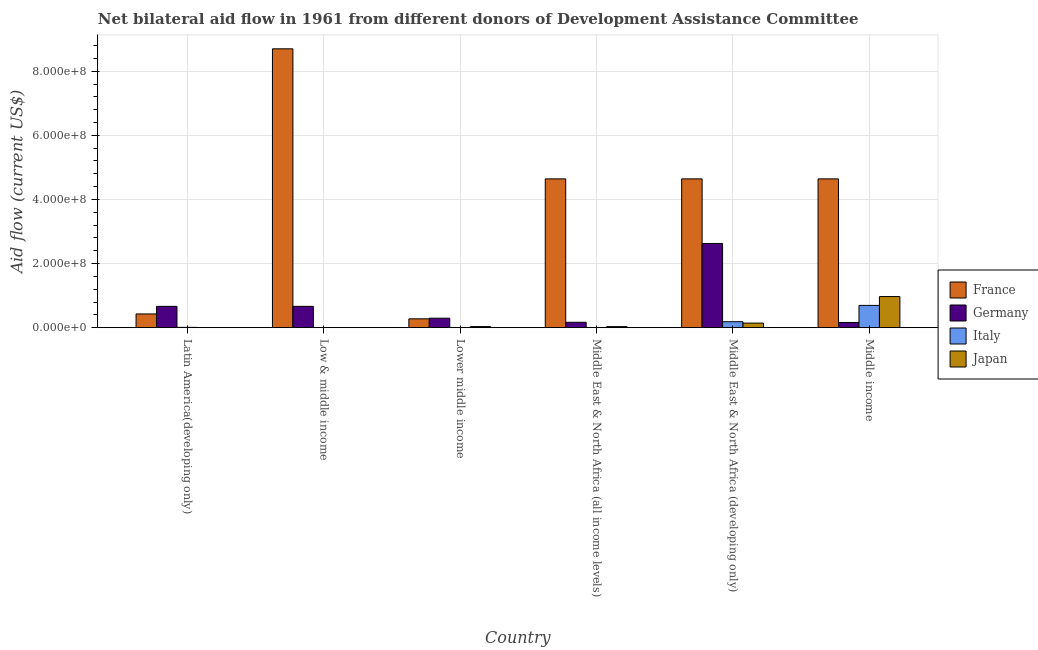How many groups of bars are there?
Your answer should be very brief. 6. Are the number of bars per tick equal to the number of legend labels?
Offer a very short reply. No. Are the number of bars on each tick of the X-axis equal?
Give a very brief answer. No. How many bars are there on the 4th tick from the left?
Keep it short and to the point. 3. What is the label of the 5th group of bars from the left?
Offer a very short reply. Middle East & North Africa (developing only). What is the amount of aid given by france in Low & middle income?
Your response must be concise. 8.70e+08. Across all countries, what is the maximum amount of aid given by italy?
Keep it short and to the point. 6.95e+07. Across all countries, what is the minimum amount of aid given by japan?
Give a very brief answer. 4.00e+04. What is the total amount of aid given by japan in the graph?
Keep it short and to the point. 1.18e+08. What is the difference between the amount of aid given by germany in Lower middle income and that in Middle East & North Africa (all income levels)?
Give a very brief answer. 1.27e+07. What is the difference between the amount of aid given by italy in Lower middle income and the amount of aid given by japan in Low & middle income?
Give a very brief answer. -4.00e+04. What is the average amount of aid given by germany per country?
Your response must be concise. 7.64e+07. What is the difference between the amount of aid given by france and amount of aid given by japan in Middle East & North Africa (all income levels)?
Your answer should be very brief. 4.61e+08. In how many countries, is the amount of aid given by germany greater than 440000000 US$?
Your answer should be compact. 0. What is the ratio of the amount of aid given by japan in Middle East & North Africa (developing only) to that in Middle income?
Ensure brevity in your answer.  0.15. Is the amount of aid given by japan in Latin America(developing only) less than that in Lower middle income?
Your answer should be compact. Yes. Is the difference between the amount of aid given by japan in Latin America(developing only) and Lower middle income greater than the difference between the amount of aid given by germany in Latin America(developing only) and Lower middle income?
Provide a short and direct response. No. What is the difference between the highest and the second highest amount of aid given by italy?
Offer a terse response. 5.10e+07. What is the difference between the highest and the lowest amount of aid given by italy?
Ensure brevity in your answer.  6.95e+07. In how many countries, is the amount of aid given by france greater than the average amount of aid given by france taken over all countries?
Your answer should be compact. 4. Is the sum of the amount of aid given by germany in Latin America(developing only) and Lower middle income greater than the maximum amount of aid given by japan across all countries?
Ensure brevity in your answer.  No. Is it the case that in every country, the sum of the amount of aid given by germany and amount of aid given by japan is greater than the sum of amount of aid given by france and amount of aid given by italy?
Keep it short and to the point. No. Is it the case that in every country, the sum of the amount of aid given by france and amount of aid given by germany is greater than the amount of aid given by italy?
Provide a short and direct response. Yes. How many countries are there in the graph?
Provide a succinct answer. 6. What is the difference between two consecutive major ticks on the Y-axis?
Offer a terse response. 2.00e+08. Are the values on the major ticks of Y-axis written in scientific E-notation?
Your answer should be compact. Yes. How are the legend labels stacked?
Make the answer very short. Vertical. What is the title of the graph?
Make the answer very short. Net bilateral aid flow in 1961 from different donors of Development Assistance Committee. Does "Water" appear as one of the legend labels in the graph?
Your answer should be compact. No. What is the label or title of the X-axis?
Offer a very short reply. Country. What is the label or title of the Y-axis?
Your response must be concise. Aid flow (current US$). What is the Aid flow (current US$) in France in Latin America(developing only)?
Provide a succinct answer. 4.28e+07. What is the Aid flow (current US$) of Germany in Latin America(developing only)?
Make the answer very short. 6.65e+07. What is the Aid flow (current US$) of Italy in Latin America(developing only)?
Make the answer very short. 9.40e+05. What is the Aid flow (current US$) of France in Low & middle income?
Your answer should be compact. 8.70e+08. What is the Aid flow (current US$) of Germany in Low & middle income?
Your response must be concise. 6.65e+07. What is the Aid flow (current US$) in Japan in Low & middle income?
Make the answer very short. 4.00e+04. What is the Aid flow (current US$) of France in Lower middle income?
Provide a succinct answer. 2.76e+07. What is the Aid flow (current US$) of Germany in Lower middle income?
Your answer should be compact. 2.95e+07. What is the Aid flow (current US$) in Italy in Lower middle income?
Provide a succinct answer. 0. What is the Aid flow (current US$) in Japan in Lower middle income?
Your answer should be very brief. 3.34e+06. What is the Aid flow (current US$) in France in Middle East & North Africa (all income levels)?
Keep it short and to the point. 4.64e+08. What is the Aid flow (current US$) in Germany in Middle East & North Africa (all income levels)?
Keep it short and to the point. 1.68e+07. What is the Aid flow (current US$) in Japan in Middle East & North Africa (all income levels)?
Offer a very short reply. 3.33e+06. What is the Aid flow (current US$) in France in Middle East & North Africa (developing only)?
Ensure brevity in your answer.  4.64e+08. What is the Aid flow (current US$) of Germany in Middle East & North Africa (developing only)?
Your answer should be very brief. 2.63e+08. What is the Aid flow (current US$) of Italy in Middle East & North Africa (developing only)?
Your response must be concise. 1.85e+07. What is the Aid flow (current US$) in Japan in Middle East & North Africa (developing only)?
Give a very brief answer. 1.43e+07. What is the Aid flow (current US$) in France in Middle income?
Keep it short and to the point. 4.64e+08. What is the Aid flow (current US$) of Germany in Middle income?
Your answer should be compact. 1.62e+07. What is the Aid flow (current US$) of Italy in Middle income?
Offer a very short reply. 6.95e+07. What is the Aid flow (current US$) of Japan in Middle income?
Make the answer very short. 9.71e+07. Across all countries, what is the maximum Aid flow (current US$) in France?
Provide a short and direct response. 8.70e+08. Across all countries, what is the maximum Aid flow (current US$) of Germany?
Make the answer very short. 2.63e+08. Across all countries, what is the maximum Aid flow (current US$) of Italy?
Make the answer very short. 6.95e+07. Across all countries, what is the maximum Aid flow (current US$) in Japan?
Offer a very short reply. 9.71e+07. Across all countries, what is the minimum Aid flow (current US$) in France?
Your answer should be compact. 2.76e+07. Across all countries, what is the minimum Aid flow (current US$) of Germany?
Give a very brief answer. 1.62e+07. Across all countries, what is the minimum Aid flow (current US$) in Japan?
Your response must be concise. 4.00e+04. What is the total Aid flow (current US$) in France in the graph?
Give a very brief answer. 2.33e+09. What is the total Aid flow (current US$) of Germany in the graph?
Keep it short and to the point. 4.58e+08. What is the total Aid flow (current US$) in Italy in the graph?
Offer a terse response. 8.90e+07. What is the total Aid flow (current US$) of Japan in the graph?
Give a very brief answer. 1.18e+08. What is the difference between the Aid flow (current US$) of France in Latin America(developing only) and that in Low & middle income?
Keep it short and to the point. -8.27e+08. What is the difference between the Aid flow (current US$) in Italy in Latin America(developing only) and that in Low & middle income?
Your response must be concise. 8.50e+05. What is the difference between the Aid flow (current US$) in France in Latin America(developing only) and that in Lower middle income?
Your answer should be compact. 1.52e+07. What is the difference between the Aid flow (current US$) of Germany in Latin America(developing only) and that in Lower middle income?
Your answer should be compact. 3.70e+07. What is the difference between the Aid flow (current US$) of Japan in Latin America(developing only) and that in Lower middle income?
Keep it short and to the point. -3.29e+06. What is the difference between the Aid flow (current US$) of France in Latin America(developing only) and that in Middle East & North Africa (all income levels)?
Offer a terse response. -4.21e+08. What is the difference between the Aid flow (current US$) of Germany in Latin America(developing only) and that in Middle East & North Africa (all income levels)?
Ensure brevity in your answer.  4.97e+07. What is the difference between the Aid flow (current US$) of Japan in Latin America(developing only) and that in Middle East & North Africa (all income levels)?
Provide a short and direct response. -3.28e+06. What is the difference between the Aid flow (current US$) of France in Latin America(developing only) and that in Middle East & North Africa (developing only)?
Your response must be concise. -4.21e+08. What is the difference between the Aid flow (current US$) in Germany in Latin America(developing only) and that in Middle East & North Africa (developing only)?
Offer a very short reply. -1.96e+08. What is the difference between the Aid flow (current US$) in Italy in Latin America(developing only) and that in Middle East & North Africa (developing only)?
Provide a succinct answer. -1.76e+07. What is the difference between the Aid flow (current US$) in Japan in Latin America(developing only) and that in Middle East & North Africa (developing only)?
Give a very brief answer. -1.42e+07. What is the difference between the Aid flow (current US$) in France in Latin America(developing only) and that in Middle income?
Keep it short and to the point. -4.21e+08. What is the difference between the Aid flow (current US$) of Germany in Latin America(developing only) and that in Middle income?
Ensure brevity in your answer.  5.03e+07. What is the difference between the Aid flow (current US$) of Italy in Latin America(developing only) and that in Middle income?
Your answer should be compact. -6.85e+07. What is the difference between the Aid flow (current US$) in Japan in Latin America(developing only) and that in Middle income?
Your answer should be very brief. -9.70e+07. What is the difference between the Aid flow (current US$) in France in Low & middle income and that in Lower middle income?
Offer a terse response. 8.42e+08. What is the difference between the Aid flow (current US$) in Germany in Low & middle income and that in Lower middle income?
Offer a very short reply. 3.70e+07. What is the difference between the Aid flow (current US$) of Japan in Low & middle income and that in Lower middle income?
Provide a short and direct response. -3.30e+06. What is the difference between the Aid flow (current US$) of France in Low & middle income and that in Middle East & North Africa (all income levels)?
Keep it short and to the point. 4.06e+08. What is the difference between the Aid flow (current US$) of Germany in Low & middle income and that in Middle East & North Africa (all income levels)?
Keep it short and to the point. 4.97e+07. What is the difference between the Aid flow (current US$) in Japan in Low & middle income and that in Middle East & North Africa (all income levels)?
Give a very brief answer. -3.29e+06. What is the difference between the Aid flow (current US$) in France in Low & middle income and that in Middle East & North Africa (developing only)?
Ensure brevity in your answer.  4.06e+08. What is the difference between the Aid flow (current US$) of Germany in Low & middle income and that in Middle East & North Africa (developing only)?
Ensure brevity in your answer.  -1.96e+08. What is the difference between the Aid flow (current US$) of Italy in Low & middle income and that in Middle East & North Africa (developing only)?
Give a very brief answer. -1.84e+07. What is the difference between the Aid flow (current US$) in Japan in Low & middle income and that in Middle East & North Africa (developing only)?
Offer a very short reply. -1.42e+07. What is the difference between the Aid flow (current US$) of France in Low & middle income and that in Middle income?
Provide a short and direct response. 4.06e+08. What is the difference between the Aid flow (current US$) in Germany in Low & middle income and that in Middle income?
Your answer should be very brief. 5.03e+07. What is the difference between the Aid flow (current US$) of Italy in Low & middle income and that in Middle income?
Offer a terse response. -6.94e+07. What is the difference between the Aid flow (current US$) of Japan in Low & middle income and that in Middle income?
Your answer should be compact. -9.70e+07. What is the difference between the Aid flow (current US$) of France in Lower middle income and that in Middle East & North Africa (all income levels)?
Offer a very short reply. -4.37e+08. What is the difference between the Aid flow (current US$) of Germany in Lower middle income and that in Middle East & North Africa (all income levels)?
Provide a succinct answer. 1.27e+07. What is the difference between the Aid flow (current US$) in France in Lower middle income and that in Middle East & North Africa (developing only)?
Your answer should be very brief. -4.37e+08. What is the difference between the Aid flow (current US$) in Germany in Lower middle income and that in Middle East & North Africa (developing only)?
Your answer should be compact. -2.33e+08. What is the difference between the Aid flow (current US$) of Japan in Lower middle income and that in Middle East & North Africa (developing only)?
Provide a succinct answer. -1.09e+07. What is the difference between the Aid flow (current US$) of France in Lower middle income and that in Middle income?
Provide a succinct answer. -4.37e+08. What is the difference between the Aid flow (current US$) of Germany in Lower middle income and that in Middle income?
Offer a very short reply. 1.33e+07. What is the difference between the Aid flow (current US$) in Japan in Lower middle income and that in Middle income?
Your response must be concise. -9.37e+07. What is the difference between the Aid flow (current US$) of France in Middle East & North Africa (all income levels) and that in Middle East & North Africa (developing only)?
Keep it short and to the point. 0. What is the difference between the Aid flow (current US$) of Germany in Middle East & North Africa (all income levels) and that in Middle East & North Africa (developing only)?
Provide a succinct answer. -2.46e+08. What is the difference between the Aid flow (current US$) in Japan in Middle East & North Africa (all income levels) and that in Middle East & North Africa (developing only)?
Your answer should be compact. -1.10e+07. What is the difference between the Aid flow (current US$) of Germany in Middle East & North Africa (all income levels) and that in Middle income?
Ensure brevity in your answer.  6.10e+05. What is the difference between the Aid flow (current US$) in Japan in Middle East & North Africa (all income levels) and that in Middle income?
Your answer should be very brief. -9.37e+07. What is the difference between the Aid flow (current US$) in France in Middle East & North Africa (developing only) and that in Middle income?
Offer a very short reply. 0. What is the difference between the Aid flow (current US$) in Germany in Middle East & North Africa (developing only) and that in Middle income?
Your answer should be compact. 2.46e+08. What is the difference between the Aid flow (current US$) of Italy in Middle East & North Africa (developing only) and that in Middle income?
Offer a terse response. -5.10e+07. What is the difference between the Aid flow (current US$) of Japan in Middle East & North Africa (developing only) and that in Middle income?
Provide a short and direct response. -8.28e+07. What is the difference between the Aid flow (current US$) in France in Latin America(developing only) and the Aid flow (current US$) in Germany in Low & middle income?
Provide a short and direct response. -2.37e+07. What is the difference between the Aid flow (current US$) of France in Latin America(developing only) and the Aid flow (current US$) of Italy in Low & middle income?
Your answer should be very brief. 4.27e+07. What is the difference between the Aid flow (current US$) of France in Latin America(developing only) and the Aid flow (current US$) of Japan in Low & middle income?
Keep it short and to the point. 4.28e+07. What is the difference between the Aid flow (current US$) of Germany in Latin America(developing only) and the Aid flow (current US$) of Italy in Low & middle income?
Give a very brief answer. 6.64e+07. What is the difference between the Aid flow (current US$) in Germany in Latin America(developing only) and the Aid flow (current US$) in Japan in Low & middle income?
Ensure brevity in your answer.  6.65e+07. What is the difference between the Aid flow (current US$) of France in Latin America(developing only) and the Aid flow (current US$) of Germany in Lower middle income?
Your answer should be compact. 1.33e+07. What is the difference between the Aid flow (current US$) in France in Latin America(developing only) and the Aid flow (current US$) in Japan in Lower middle income?
Provide a short and direct response. 3.95e+07. What is the difference between the Aid flow (current US$) in Germany in Latin America(developing only) and the Aid flow (current US$) in Japan in Lower middle income?
Your answer should be very brief. 6.32e+07. What is the difference between the Aid flow (current US$) of Italy in Latin America(developing only) and the Aid flow (current US$) of Japan in Lower middle income?
Make the answer very short. -2.40e+06. What is the difference between the Aid flow (current US$) in France in Latin America(developing only) and the Aid flow (current US$) in Germany in Middle East & North Africa (all income levels)?
Ensure brevity in your answer.  2.60e+07. What is the difference between the Aid flow (current US$) of France in Latin America(developing only) and the Aid flow (current US$) of Japan in Middle East & North Africa (all income levels)?
Your answer should be very brief. 3.95e+07. What is the difference between the Aid flow (current US$) in Germany in Latin America(developing only) and the Aid flow (current US$) in Japan in Middle East & North Africa (all income levels)?
Ensure brevity in your answer.  6.32e+07. What is the difference between the Aid flow (current US$) in Italy in Latin America(developing only) and the Aid flow (current US$) in Japan in Middle East & North Africa (all income levels)?
Provide a succinct answer. -2.39e+06. What is the difference between the Aid flow (current US$) in France in Latin America(developing only) and the Aid flow (current US$) in Germany in Middle East & North Africa (developing only)?
Provide a succinct answer. -2.20e+08. What is the difference between the Aid flow (current US$) in France in Latin America(developing only) and the Aid flow (current US$) in Italy in Middle East & North Africa (developing only)?
Your answer should be compact. 2.43e+07. What is the difference between the Aid flow (current US$) in France in Latin America(developing only) and the Aid flow (current US$) in Japan in Middle East & North Africa (developing only)?
Your response must be concise. 2.85e+07. What is the difference between the Aid flow (current US$) in Germany in Latin America(developing only) and the Aid flow (current US$) in Italy in Middle East & North Africa (developing only)?
Keep it short and to the point. 4.80e+07. What is the difference between the Aid flow (current US$) of Germany in Latin America(developing only) and the Aid flow (current US$) of Japan in Middle East & North Africa (developing only)?
Offer a terse response. 5.22e+07. What is the difference between the Aid flow (current US$) in Italy in Latin America(developing only) and the Aid flow (current US$) in Japan in Middle East & North Africa (developing only)?
Your answer should be very brief. -1.33e+07. What is the difference between the Aid flow (current US$) of France in Latin America(developing only) and the Aid flow (current US$) of Germany in Middle income?
Make the answer very short. 2.66e+07. What is the difference between the Aid flow (current US$) of France in Latin America(developing only) and the Aid flow (current US$) of Italy in Middle income?
Your answer should be very brief. -2.67e+07. What is the difference between the Aid flow (current US$) in France in Latin America(developing only) and the Aid flow (current US$) in Japan in Middle income?
Give a very brief answer. -5.43e+07. What is the difference between the Aid flow (current US$) in Germany in Latin America(developing only) and the Aid flow (current US$) in Italy in Middle income?
Make the answer very short. -2.97e+06. What is the difference between the Aid flow (current US$) in Germany in Latin America(developing only) and the Aid flow (current US$) in Japan in Middle income?
Make the answer very short. -3.06e+07. What is the difference between the Aid flow (current US$) in Italy in Latin America(developing only) and the Aid flow (current US$) in Japan in Middle income?
Ensure brevity in your answer.  -9.61e+07. What is the difference between the Aid flow (current US$) of France in Low & middle income and the Aid flow (current US$) of Germany in Lower middle income?
Provide a succinct answer. 8.40e+08. What is the difference between the Aid flow (current US$) in France in Low & middle income and the Aid flow (current US$) in Japan in Lower middle income?
Offer a very short reply. 8.67e+08. What is the difference between the Aid flow (current US$) in Germany in Low & middle income and the Aid flow (current US$) in Japan in Lower middle income?
Your response must be concise. 6.32e+07. What is the difference between the Aid flow (current US$) in Italy in Low & middle income and the Aid flow (current US$) in Japan in Lower middle income?
Make the answer very short. -3.25e+06. What is the difference between the Aid flow (current US$) of France in Low & middle income and the Aid flow (current US$) of Germany in Middle East & North Africa (all income levels)?
Give a very brief answer. 8.53e+08. What is the difference between the Aid flow (current US$) of France in Low & middle income and the Aid flow (current US$) of Japan in Middle East & North Africa (all income levels)?
Your response must be concise. 8.67e+08. What is the difference between the Aid flow (current US$) in Germany in Low & middle income and the Aid flow (current US$) in Japan in Middle East & North Africa (all income levels)?
Your answer should be very brief. 6.32e+07. What is the difference between the Aid flow (current US$) in Italy in Low & middle income and the Aid flow (current US$) in Japan in Middle East & North Africa (all income levels)?
Ensure brevity in your answer.  -3.24e+06. What is the difference between the Aid flow (current US$) of France in Low & middle income and the Aid flow (current US$) of Germany in Middle East & North Africa (developing only)?
Give a very brief answer. 6.07e+08. What is the difference between the Aid flow (current US$) of France in Low & middle income and the Aid flow (current US$) of Italy in Middle East & North Africa (developing only)?
Offer a very short reply. 8.51e+08. What is the difference between the Aid flow (current US$) of France in Low & middle income and the Aid flow (current US$) of Japan in Middle East & North Africa (developing only)?
Keep it short and to the point. 8.56e+08. What is the difference between the Aid flow (current US$) of Germany in Low & middle income and the Aid flow (current US$) of Italy in Middle East & North Africa (developing only)?
Keep it short and to the point. 4.80e+07. What is the difference between the Aid flow (current US$) in Germany in Low & middle income and the Aid flow (current US$) in Japan in Middle East & North Africa (developing only)?
Give a very brief answer. 5.22e+07. What is the difference between the Aid flow (current US$) in Italy in Low & middle income and the Aid flow (current US$) in Japan in Middle East & North Africa (developing only)?
Your answer should be very brief. -1.42e+07. What is the difference between the Aid flow (current US$) in France in Low & middle income and the Aid flow (current US$) in Germany in Middle income?
Ensure brevity in your answer.  8.54e+08. What is the difference between the Aid flow (current US$) of France in Low & middle income and the Aid flow (current US$) of Italy in Middle income?
Make the answer very short. 8.01e+08. What is the difference between the Aid flow (current US$) in France in Low & middle income and the Aid flow (current US$) in Japan in Middle income?
Make the answer very short. 7.73e+08. What is the difference between the Aid flow (current US$) of Germany in Low & middle income and the Aid flow (current US$) of Italy in Middle income?
Provide a succinct answer. -2.97e+06. What is the difference between the Aid flow (current US$) of Germany in Low & middle income and the Aid flow (current US$) of Japan in Middle income?
Provide a succinct answer. -3.06e+07. What is the difference between the Aid flow (current US$) in Italy in Low & middle income and the Aid flow (current US$) in Japan in Middle income?
Make the answer very short. -9.70e+07. What is the difference between the Aid flow (current US$) of France in Lower middle income and the Aid flow (current US$) of Germany in Middle East & North Africa (all income levels)?
Offer a terse response. 1.08e+07. What is the difference between the Aid flow (current US$) of France in Lower middle income and the Aid flow (current US$) of Japan in Middle East & North Africa (all income levels)?
Make the answer very short. 2.43e+07. What is the difference between the Aid flow (current US$) in Germany in Lower middle income and the Aid flow (current US$) in Japan in Middle East & North Africa (all income levels)?
Provide a succinct answer. 2.62e+07. What is the difference between the Aid flow (current US$) in France in Lower middle income and the Aid flow (current US$) in Germany in Middle East & North Africa (developing only)?
Make the answer very short. -2.35e+08. What is the difference between the Aid flow (current US$) of France in Lower middle income and the Aid flow (current US$) of Italy in Middle East & North Africa (developing only)?
Provide a succinct answer. 9.08e+06. What is the difference between the Aid flow (current US$) in France in Lower middle income and the Aid flow (current US$) in Japan in Middle East & North Africa (developing only)?
Give a very brief answer. 1.33e+07. What is the difference between the Aid flow (current US$) in Germany in Lower middle income and the Aid flow (current US$) in Italy in Middle East & North Africa (developing only)?
Offer a terse response. 1.10e+07. What is the difference between the Aid flow (current US$) of Germany in Lower middle income and the Aid flow (current US$) of Japan in Middle East & North Africa (developing only)?
Give a very brief answer. 1.52e+07. What is the difference between the Aid flow (current US$) of France in Lower middle income and the Aid flow (current US$) of Germany in Middle income?
Provide a short and direct response. 1.14e+07. What is the difference between the Aid flow (current US$) in France in Lower middle income and the Aid flow (current US$) in Italy in Middle income?
Offer a very short reply. -4.19e+07. What is the difference between the Aid flow (current US$) in France in Lower middle income and the Aid flow (current US$) in Japan in Middle income?
Offer a very short reply. -6.95e+07. What is the difference between the Aid flow (current US$) in Germany in Lower middle income and the Aid flow (current US$) in Italy in Middle income?
Your response must be concise. -4.00e+07. What is the difference between the Aid flow (current US$) of Germany in Lower middle income and the Aid flow (current US$) of Japan in Middle income?
Your answer should be very brief. -6.75e+07. What is the difference between the Aid flow (current US$) in France in Middle East & North Africa (all income levels) and the Aid flow (current US$) in Germany in Middle East & North Africa (developing only)?
Keep it short and to the point. 2.02e+08. What is the difference between the Aid flow (current US$) of France in Middle East & North Africa (all income levels) and the Aid flow (current US$) of Italy in Middle East & North Africa (developing only)?
Make the answer very short. 4.46e+08. What is the difference between the Aid flow (current US$) of France in Middle East & North Africa (all income levels) and the Aid flow (current US$) of Japan in Middle East & North Africa (developing only)?
Your answer should be very brief. 4.50e+08. What is the difference between the Aid flow (current US$) of Germany in Middle East & North Africa (all income levels) and the Aid flow (current US$) of Italy in Middle East & North Africa (developing only)?
Make the answer very short. -1.71e+06. What is the difference between the Aid flow (current US$) of Germany in Middle East & North Africa (all income levels) and the Aid flow (current US$) of Japan in Middle East & North Africa (developing only)?
Offer a terse response. 2.53e+06. What is the difference between the Aid flow (current US$) of France in Middle East & North Africa (all income levels) and the Aid flow (current US$) of Germany in Middle income?
Your response must be concise. 4.48e+08. What is the difference between the Aid flow (current US$) of France in Middle East & North Africa (all income levels) and the Aid flow (current US$) of Italy in Middle income?
Your answer should be compact. 3.95e+08. What is the difference between the Aid flow (current US$) of France in Middle East & North Africa (all income levels) and the Aid flow (current US$) of Japan in Middle income?
Give a very brief answer. 3.67e+08. What is the difference between the Aid flow (current US$) in Germany in Middle East & North Africa (all income levels) and the Aid flow (current US$) in Italy in Middle income?
Offer a very short reply. -5.27e+07. What is the difference between the Aid flow (current US$) of Germany in Middle East & North Africa (all income levels) and the Aid flow (current US$) of Japan in Middle income?
Give a very brief answer. -8.02e+07. What is the difference between the Aid flow (current US$) of France in Middle East & North Africa (developing only) and the Aid flow (current US$) of Germany in Middle income?
Keep it short and to the point. 4.48e+08. What is the difference between the Aid flow (current US$) of France in Middle East & North Africa (developing only) and the Aid flow (current US$) of Italy in Middle income?
Make the answer very short. 3.95e+08. What is the difference between the Aid flow (current US$) of France in Middle East & North Africa (developing only) and the Aid flow (current US$) of Japan in Middle income?
Offer a very short reply. 3.67e+08. What is the difference between the Aid flow (current US$) of Germany in Middle East & North Africa (developing only) and the Aid flow (current US$) of Italy in Middle income?
Make the answer very short. 1.93e+08. What is the difference between the Aid flow (current US$) in Germany in Middle East & North Africa (developing only) and the Aid flow (current US$) in Japan in Middle income?
Your answer should be compact. 1.66e+08. What is the difference between the Aid flow (current US$) of Italy in Middle East & North Africa (developing only) and the Aid flow (current US$) of Japan in Middle income?
Give a very brief answer. -7.85e+07. What is the average Aid flow (current US$) in France per country?
Your answer should be compact. 3.89e+08. What is the average Aid flow (current US$) of Germany per country?
Provide a succinct answer. 7.64e+07. What is the average Aid flow (current US$) of Italy per country?
Your answer should be compact. 1.48e+07. What is the average Aid flow (current US$) of Japan per country?
Your answer should be very brief. 1.97e+07. What is the difference between the Aid flow (current US$) in France and Aid flow (current US$) in Germany in Latin America(developing only)?
Your response must be concise. -2.37e+07. What is the difference between the Aid flow (current US$) of France and Aid flow (current US$) of Italy in Latin America(developing only)?
Provide a succinct answer. 4.19e+07. What is the difference between the Aid flow (current US$) in France and Aid flow (current US$) in Japan in Latin America(developing only)?
Keep it short and to the point. 4.28e+07. What is the difference between the Aid flow (current US$) of Germany and Aid flow (current US$) of Italy in Latin America(developing only)?
Give a very brief answer. 6.56e+07. What is the difference between the Aid flow (current US$) of Germany and Aid flow (current US$) of Japan in Latin America(developing only)?
Provide a succinct answer. 6.65e+07. What is the difference between the Aid flow (current US$) in Italy and Aid flow (current US$) in Japan in Latin America(developing only)?
Your answer should be compact. 8.90e+05. What is the difference between the Aid flow (current US$) in France and Aid flow (current US$) in Germany in Low & middle income?
Your answer should be very brief. 8.03e+08. What is the difference between the Aid flow (current US$) in France and Aid flow (current US$) in Italy in Low & middle income?
Offer a very short reply. 8.70e+08. What is the difference between the Aid flow (current US$) of France and Aid flow (current US$) of Japan in Low & middle income?
Provide a short and direct response. 8.70e+08. What is the difference between the Aid flow (current US$) of Germany and Aid flow (current US$) of Italy in Low & middle income?
Your response must be concise. 6.64e+07. What is the difference between the Aid flow (current US$) of Germany and Aid flow (current US$) of Japan in Low & middle income?
Ensure brevity in your answer.  6.65e+07. What is the difference between the Aid flow (current US$) in France and Aid flow (current US$) in Germany in Lower middle income?
Make the answer very short. -1.92e+06. What is the difference between the Aid flow (current US$) in France and Aid flow (current US$) in Japan in Lower middle income?
Your answer should be compact. 2.43e+07. What is the difference between the Aid flow (current US$) of Germany and Aid flow (current US$) of Japan in Lower middle income?
Offer a very short reply. 2.62e+07. What is the difference between the Aid flow (current US$) in France and Aid flow (current US$) in Germany in Middle East & North Africa (all income levels)?
Ensure brevity in your answer.  4.47e+08. What is the difference between the Aid flow (current US$) in France and Aid flow (current US$) in Japan in Middle East & North Africa (all income levels)?
Keep it short and to the point. 4.61e+08. What is the difference between the Aid flow (current US$) of Germany and Aid flow (current US$) of Japan in Middle East & North Africa (all income levels)?
Give a very brief answer. 1.35e+07. What is the difference between the Aid flow (current US$) in France and Aid flow (current US$) in Germany in Middle East & North Africa (developing only)?
Your answer should be compact. 2.02e+08. What is the difference between the Aid flow (current US$) in France and Aid flow (current US$) in Italy in Middle East & North Africa (developing only)?
Your answer should be very brief. 4.46e+08. What is the difference between the Aid flow (current US$) of France and Aid flow (current US$) of Japan in Middle East & North Africa (developing only)?
Your answer should be compact. 4.50e+08. What is the difference between the Aid flow (current US$) in Germany and Aid flow (current US$) in Italy in Middle East & North Africa (developing only)?
Ensure brevity in your answer.  2.44e+08. What is the difference between the Aid flow (current US$) in Germany and Aid flow (current US$) in Japan in Middle East & North Africa (developing only)?
Your response must be concise. 2.48e+08. What is the difference between the Aid flow (current US$) of Italy and Aid flow (current US$) of Japan in Middle East & North Africa (developing only)?
Provide a succinct answer. 4.24e+06. What is the difference between the Aid flow (current US$) in France and Aid flow (current US$) in Germany in Middle income?
Provide a short and direct response. 4.48e+08. What is the difference between the Aid flow (current US$) in France and Aid flow (current US$) in Italy in Middle income?
Provide a succinct answer. 3.95e+08. What is the difference between the Aid flow (current US$) in France and Aid flow (current US$) in Japan in Middle income?
Your answer should be very brief. 3.67e+08. What is the difference between the Aid flow (current US$) in Germany and Aid flow (current US$) in Italy in Middle income?
Your response must be concise. -5.33e+07. What is the difference between the Aid flow (current US$) of Germany and Aid flow (current US$) of Japan in Middle income?
Make the answer very short. -8.09e+07. What is the difference between the Aid flow (current US$) of Italy and Aid flow (current US$) of Japan in Middle income?
Provide a short and direct response. -2.76e+07. What is the ratio of the Aid flow (current US$) of France in Latin America(developing only) to that in Low & middle income?
Ensure brevity in your answer.  0.05. What is the ratio of the Aid flow (current US$) of Germany in Latin America(developing only) to that in Low & middle income?
Ensure brevity in your answer.  1. What is the ratio of the Aid flow (current US$) of Italy in Latin America(developing only) to that in Low & middle income?
Give a very brief answer. 10.44. What is the ratio of the Aid flow (current US$) in France in Latin America(developing only) to that in Lower middle income?
Your answer should be compact. 1.55. What is the ratio of the Aid flow (current US$) in Germany in Latin America(developing only) to that in Lower middle income?
Ensure brevity in your answer.  2.25. What is the ratio of the Aid flow (current US$) of Japan in Latin America(developing only) to that in Lower middle income?
Provide a short and direct response. 0.01. What is the ratio of the Aid flow (current US$) in France in Latin America(developing only) to that in Middle East & North Africa (all income levels)?
Your response must be concise. 0.09. What is the ratio of the Aid flow (current US$) of Germany in Latin America(developing only) to that in Middle East & North Africa (all income levels)?
Your answer should be compact. 3.96. What is the ratio of the Aid flow (current US$) in Japan in Latin America(developing only) to that in Middle East & North Africa (all income levels)?
Make the answer very short. 0.01. What is the ratio of the Aid flow (current US$) in France in Latin America(developing only) to that in Middle East & North Africa (developing only)?
Your response must be concise. 0.09. What is the ratio of the Aid flow (current US$) of Germany in Latin America(developing only) to that in Middle East & North Africa (developing only)?
Offer a very short reply. 0.25. What is the ratio of the Aid flow (current US$) of Italy in Latin America(developing only) to that in Middle East & North Africa (developing only)?
Keep it short and to the point. 0.05. What is the ratio of the Aid flow (current US$) in Japan in Latin America(developing only) to that in Middle East & North Africa (developing only)?
Your answer should be very brief. 0. What is the ratio of the Aid flow (current US$) of France in Latin America(developing only) to that in Middle income?
Give a very brief answer. 0.09. What is the ratio of the Aid flow (current US$) of Germany in Latin America(developing only) to that in Middle income?
Keep it short and to the point. 4.11. What is the ratio of the Aid flow (current US$) in Italy in Latin America(developing only) to that in Middle income?
Offer a terse response. 0.01. What is the ratio of the Aid flow (current US$) in France in Low & middle income to that in Lower middle income?
Provide a succinct answer. 31.52. What is the ratio of the Aid flow (current US$) of Germany in Low & middle income to that in Lower middle income?
Give a very brief answer. 2.25. What is the ratio of the Aid flow (current US$) of Japan in Low & middle income to that in Lower middle income?
Keep it short and to the point. 0.01. What is the ratio of the Aid flow (current US$) in France in Low & middle income to that in Middle East & North Africa (all income levels)?
Make the answer very short. 1.87. What is the ratio of the Aid flow (current US$) of Germany in Low & middle income to that in Middle East & North Africa (all income levels)?
Your answer should be compact. 3.96. What is the ratio of the Aid flow (current US$) in Japan in Low & middle income to that in Middle East & North Africa (all income levels)?
Make the answer very short. 0.01. What is the ratio of the Aid flow (current US$) in France in Low & middle income to that in Middle East & North Africa (developing only)?
Your answer should be compact. 1.87. What is the ratio of the Aid flow (current US$) in Germany in Low & middle income to that in Middle East & North Africa (developing only)?
Provide a short and direct response. 0.25. What is the ratio of the Aid flow (current US$) of Italy in Low & middle income to that in Middle East & North Africa (developing only)?
Keep it short and to the point. 0. What is the ratio of the Aid flow (current US$) in Japan in Low & middle income to that in Middle East & North Africa (developing only)?
Keep it short and to the point. 0. What is the ratio of the Aid flow (current US$) in France in Low & middle income to that in Middle income?
Your response must be concise. 1.87. What is the ratio of the Aid flow (current US$) in Germany in Low & middle income to that in Middle income?
Keep it short and to the point. 4.11. What is the ratio of the Aid flow (current US$) of Italy in Low & middle income to that in Middle income?
Provide a succinct answer. 0. What is the ratio of the Aid flow (current US$) of Japan in Low & middle income to that in Middle income?
Give a very brief answer. 0. What is the ratio of the Aid flow (current US$) in France in Lower middle income to that in Middle East & North Africa (all income levels)?
Ensure brevity in your answer.  0.06. What is the ratio of the Aid flow (current US$) of Germany in Lower middle income to that in Middle East & North Africa (all income levels)?
Provide a succinct answer. 1.76. What is the ratio of the Aid flow (current US$) in Japan in Lower middle income to that in Middle East & North Africa (all income levels)?
Make the answer very short. 1. What is the ratio of the Aid flow (current US$) of France in Lower middle income to that in Middle East & North Africa (developing only)?
Give a very brief answer. 0.06. What is the ratio of the Aid flow (current US$) in Germany in Lower middle income to that in Middle East & North Africa (developing only)?
Your answer should be very brief. 0.11. What is the ratio of the Aid flow (current US$) of Japan in Lower middle income to that in Middle East & North Africa (developing only)?
Your answer should be very brief. 0.23. What is the ratio of the Aid flow (current US$) of France in Lower middle income to that in Middle income?
Make the answer very short. 0.06. What is the ratio of the Aid flow (current US$) in Germany in Lower middle income to that in Middle income?
Offer a very short reply. 1.82. What is the ratio of the Aid flow (current US$) in Japan in Lower middle income to that in Middle income?
Your response must be concise. 0.03. What is the ratio of the Aid flow (current US$) of France in Middle East & North Africa (all income levels) to that in Middle East & North Africa (developing only)?
Ensure brevity in your answer.  1. What is the ratio of the Aid flow (current US$) of Germany in Middle East & North Africa (all income levels) to that in Middle East & North Africa (developing only)?
Provide a succinct answer. 0.06. What is the ratio of the Aid flow (current US$) in Japan in Middle East & North Africa (all income levels) to that in Middle East & North Africa (developing only)?
Provide a short and direct response. 0.23. What is the ratio of the Aid flow (current US$) in France in Middle East & North Africa (all income levels) to that in Middle income?
Your response must be concise. 1. What is the ratio of the Aid flow (current US$) in Germany in Middle East & North Africa (all income levels) to that in Middle income?
Offer a terse response. 1.04. What is the ratio of the Aid flow (current US$) of Japan in Middle East & North Africa (all income levels) to that in Middle income?
Provide a succinct answer. 0.03. What is the ratio of the Aid flow (current US$) in France in Middle East & North Africa (developing only) to that in Middle income?
Ensure brevity in your answer.  1. What is the ratio of the Aid flow (current US$) of Germany in Middle East & North Africa (developing only) to that in Middle income?
Provide a short and direct response. 16.21. What is the ratio of the Aid flow (current US$) of Italy in Middle East & North Africa (developing only) to that in Middle income?
Ensure brevity in your answer.  0.27. What is the ratio of the Aid flow (current US$) of Japan in Middle East & North Africa (developing only) to that in Middle income?
Keep it short and to the point. 0.15. What is the difference between the highest and the second highest Aid flow (current US$) in France?
Offer a very short reply. 4.06e+08. What is the difference between the highest and the second highest Aid flow (current US$) of Germany?
Provide a short and direct response. 1.96e+08. What is the difference between the highest and the second highest Aid flow (current US$) in Italy?
Make the answer very short. 5.10e+07. What is the difference between the highest and the second highest Aid flow (current US$) in Japan?
Provide a short and direct response. 8.28e+07. What is the difference between the highest and the lowest Aid flow (current US$) in France?
Your response must be concise. 8.42e+08. What is the difference between the highest and the lowest Aid flow (current US$) in Germany?
Offer a very short reply. 2.46e+08. What is the difference between the highest and the lowest Aid flow (current US$) in Italy?
Ensure brevity in your answer.  6.95e+07. What is the difference between the highest and the lowest Aid flow (current US$) in Japan?
Make the answer very short. 9.70e+07. 